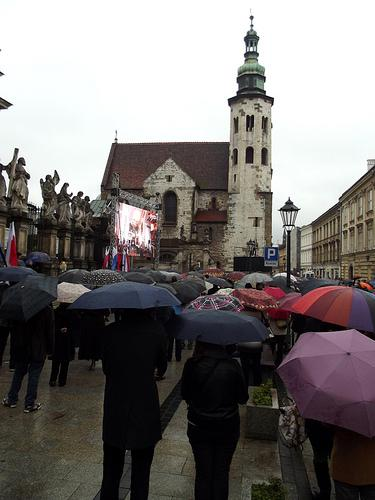Question: what is the picture showing?
Choices:
A. A zebra.
B. Lots of people with umbrellas.
C. A horse.
D. A giraffe.
Answer with the letter. Answer: B Question: when was the picture taken?
Choices:
A. At night.
B. Morning.
C. Noon.
D. During the day.
Answer with the letter. Answer: D Question: what the majority color of umbrellas?
Choices:
A. White.
B. Gray.
C. Red.
D. Black.
Answer with the letter. Answer: D Question: who is holding umbrella's?
Choices:
A. Japanese people.
B. Children.
C. People.
D. Adults.
Answer with the letter. Answer: C Question: what is in the planters on the ground?
Choices:
A. Coleus.
B. Plants.
C. Roses.
D. Lantana.
Answer with the letter. Answer: B Question: where are the people standing?
Choices:
A. On the ground.
B. In the field.
C. By their cars.
D. In line.
Answer with the letter. Answer: A 